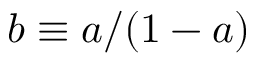<formula> <loc_0><loc_0><loc_500><loc_500>b \equiv a / ( 1 - a )</formula> 